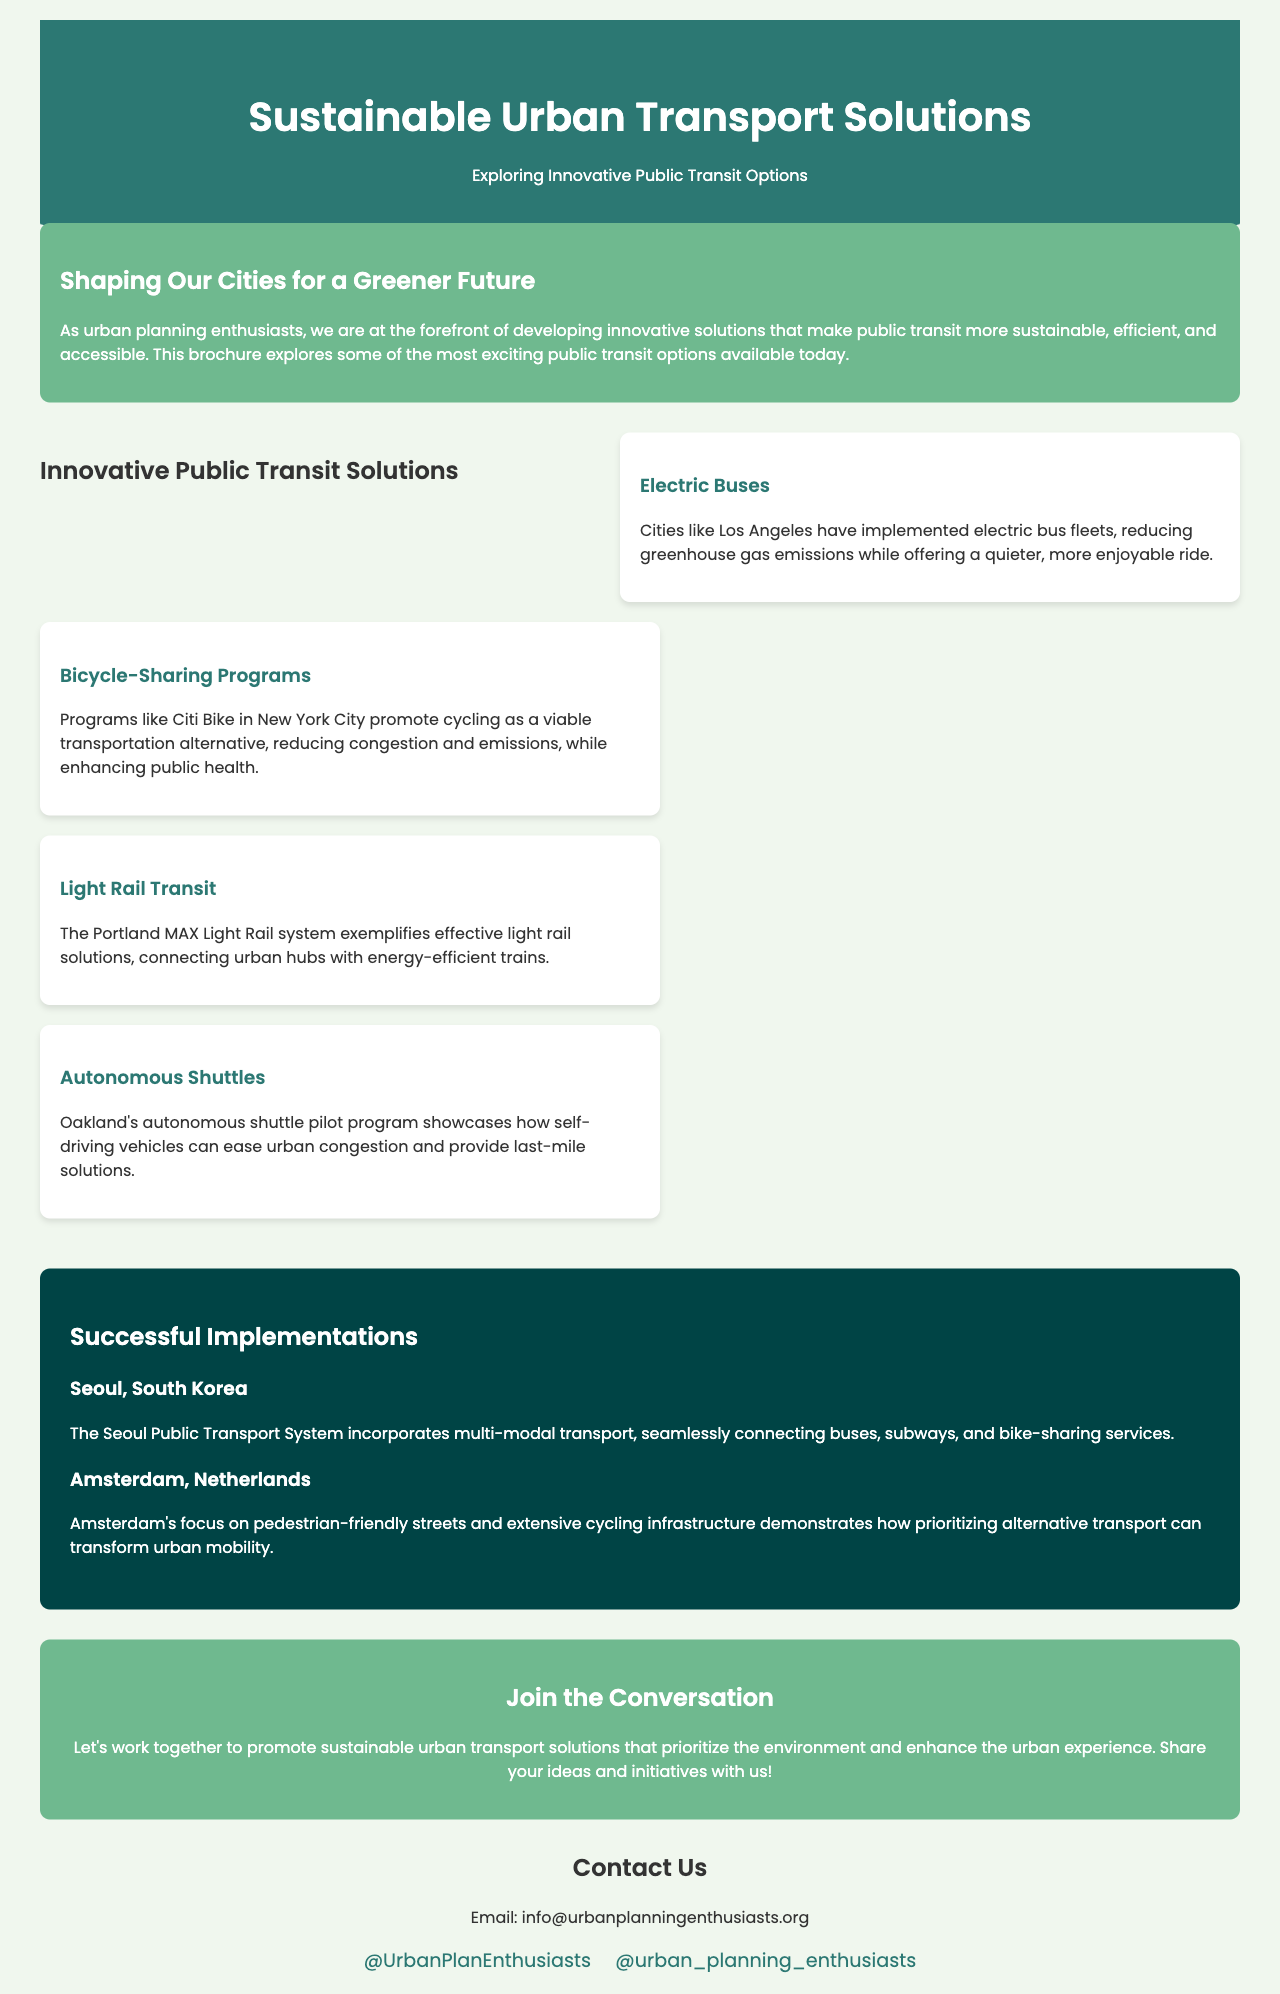What is the title of the brochure? The title is displayed prominently at the top of the document in the header section.
Answer: Sustainable Urban Transport Solutions Who implemented electric bus fleets? The document mentions a specific city that has adopted this solution, providing an example for electric buses.
Answer: Los Angeles What program promotes cycling in New York City? This question refers to a specific initiative that encourages cycling as an alternative transportation option.
Answer: Citi Bike What type of transport system does Seoul incorporate? The document highlights a distinctive feature of the transport system in Seoul that connects various modes of transport.
Answer: Multi-modal transport Which city is highlighted for its autonomous shuttle program? This question directs attention to a specific city that features a pilot program using autonomous vehicles.
Answer: Oakland How does Amsterdam prioritize urban mobility? This question seeks to understand the approach taken by Amsterdam towards urban transportation alternatives, as outlined in the case study.
Answer: Pedestrian-friendly streets What color is used for the conclusion section? This question addresses a design element of the brochure, focusing on the color scheme for a specific section.
Answer: Green How many innovative public transit solutions are listed? The response will require counting the number of solutions presented in the section about innovative transit options.
Answer: Four 